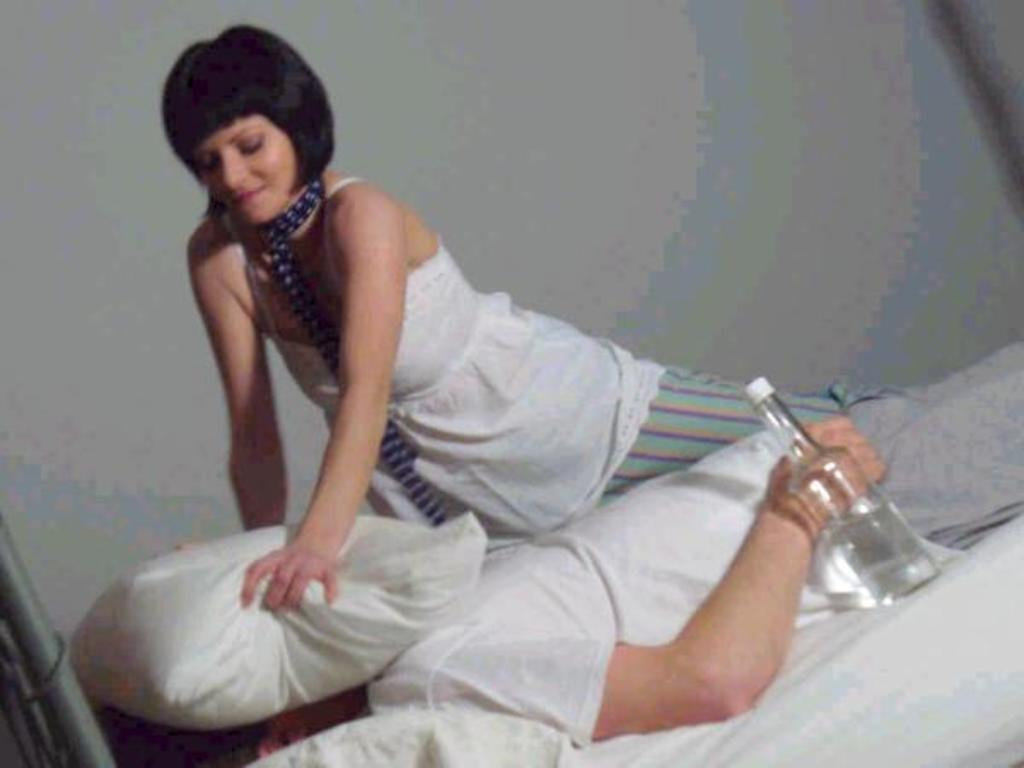What is the person in the image doing? There is a person lying on the bed in the image. What object can be seen near the person? There is a water bottle in the image. What is the lady holding in the image? The lady is holding a pillow in the image. What can be seen in the background of the image? There is a wall in the background of the image. How many cacti are present on the shelf in the image? There is no shelf or cactus present in the image. What type of love is being expressed in the image? There is no indication of love being expressed in the image; it features a person lying on a bed and a lady holding a pillow. 